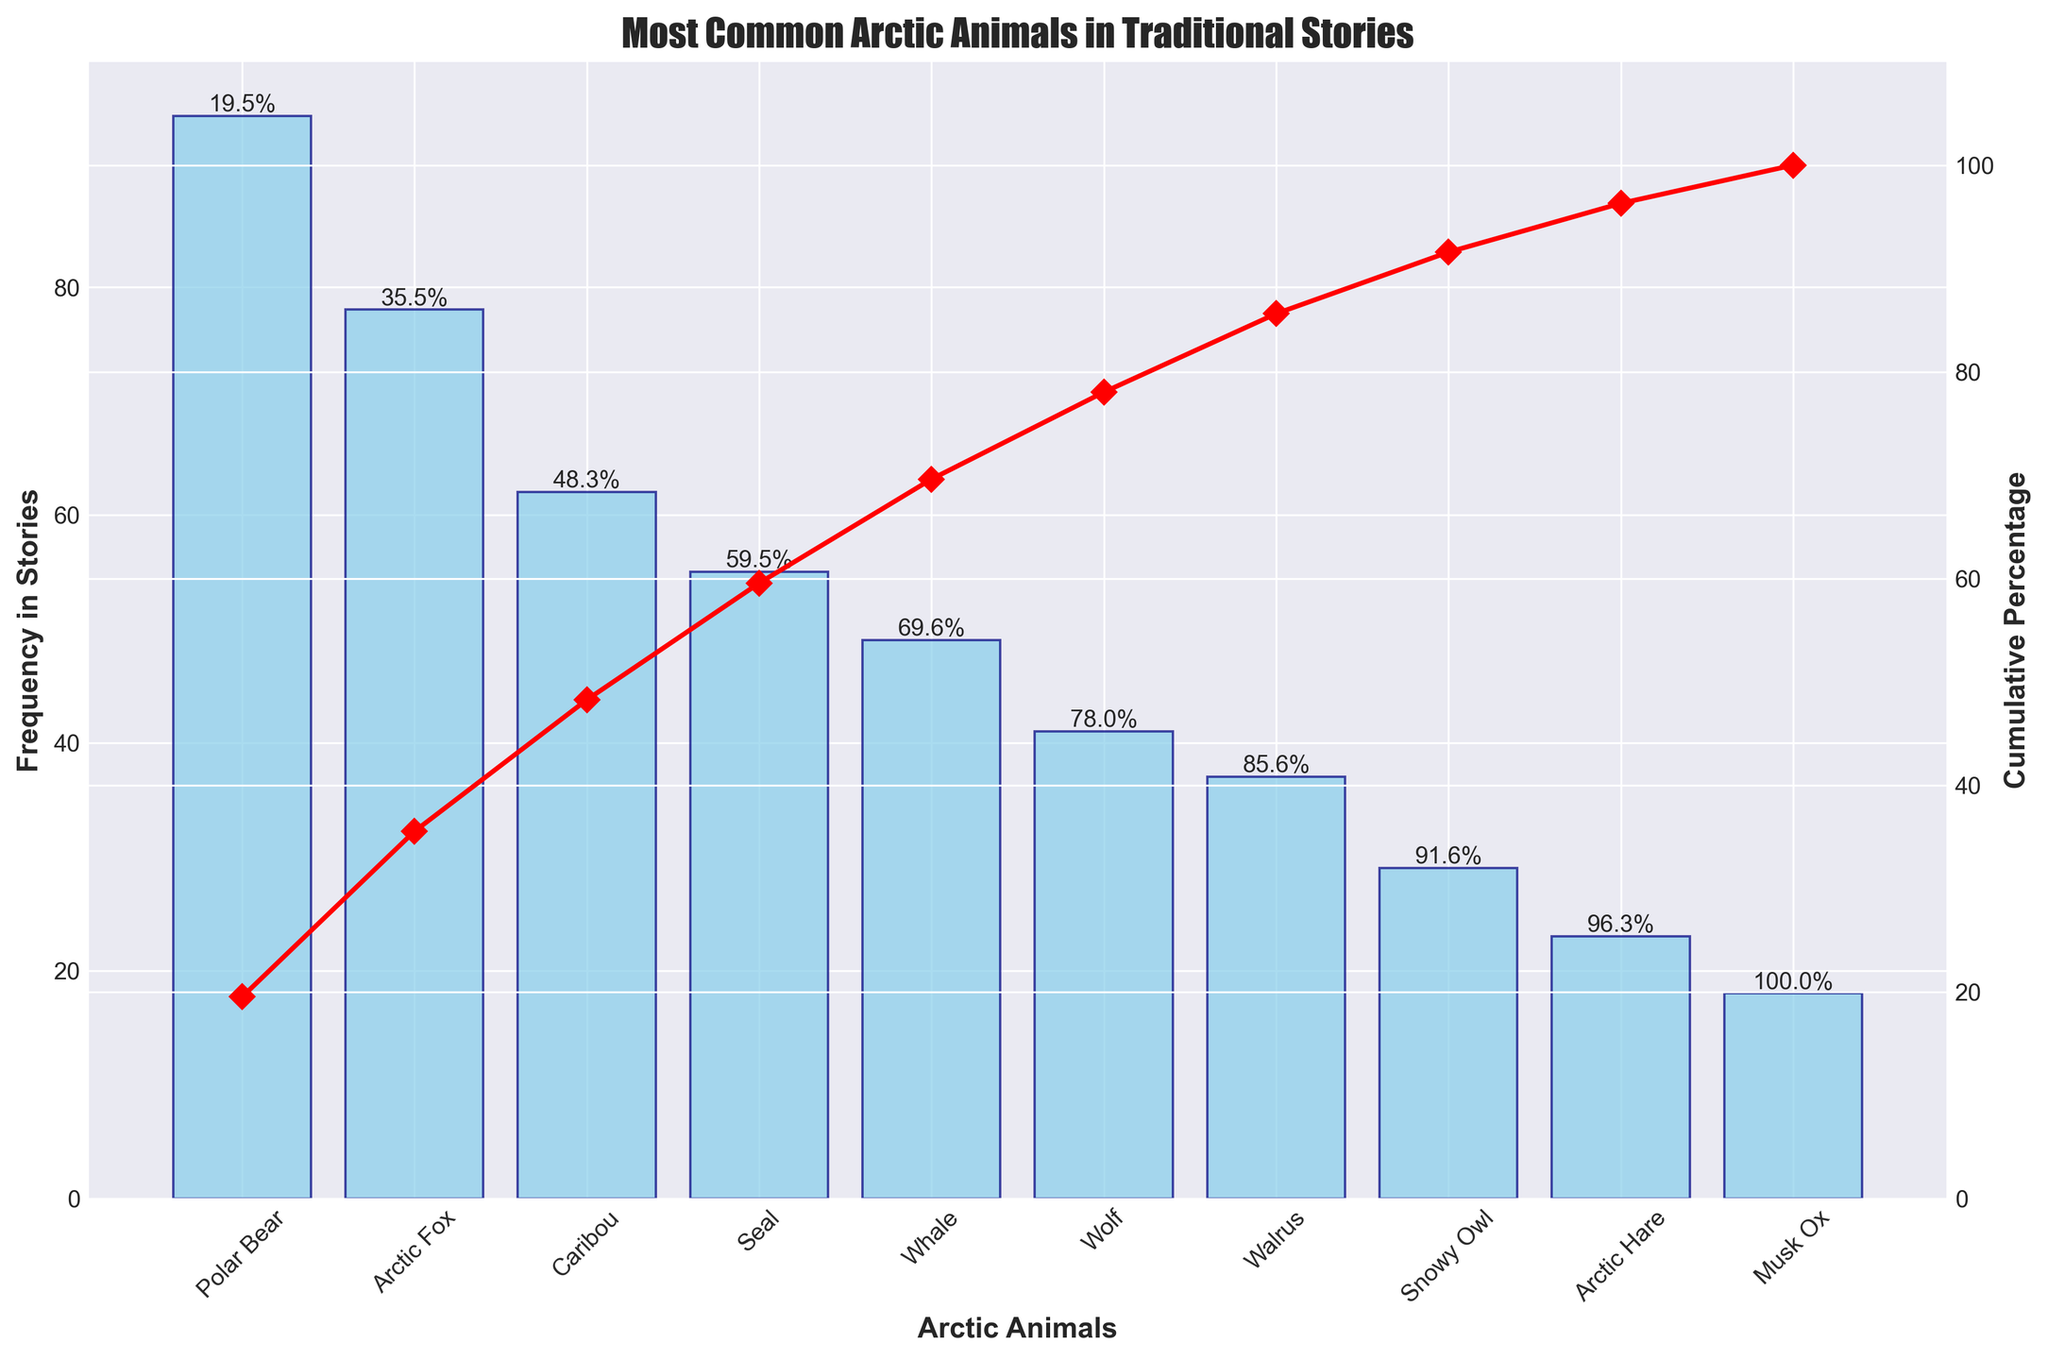What's the title of the figure? The title of a figure is usually located at the top center and describes the main topic of the visualization.
Answer: Most Common Arctic Animals in Traditional Stories What animal is mentioned the most in traditional stories? The tallest bar in the chart represents the animal with the highest frequency.
Answer: Polar Bear What is the cumulative percentage when we include the Arctic Fox? To find this, add the frequencies of the Polar Bear and the Arctic Fox and divide by the total frequency to get the cumulative percentage indicated on the red line.
Answer: 60.9% Which animal has the lowest frequency mentioned in traditional stories? The smallest bar in the chart represents the animal with the lowest frequency.
Answer: Musk Ox How many animals have a frequency in stories greater than or equal to 50? Count the bars that have a height of 50 or above.
Answer: 4 What is the cumulative percentage after including the Caribou? Calculate the cumulative sum of frequencies including Polar Bear, Arctic Fox, and Caribou, then divide by the total frequency.
Answer: 77.0% Which animals have a frequency between 30 and 50 in the stories? Identify the bars within the range of 30 to 50 in height.
Answer: Whale, Wolf Why does the figure have two y-axes (one on each side)? One y-axis (left) shows the frequency of mentions, while the other y-axis (right) represents the cumulative percentage. This dual-axis helps understand frequency and cumulative impact simultaneously.
Answer: To display frequency and cumulative percentage How many animals have a frequency less than that of the Walrus? Count the bars that are shorter than the Walrus bar.
Answer: 3 What is the frequency difference between the Polar Bear and the Snowy Owl? Subtract the frequency of the Snowy Owl from the frequency of the Polar Bear.
Answer: 66 